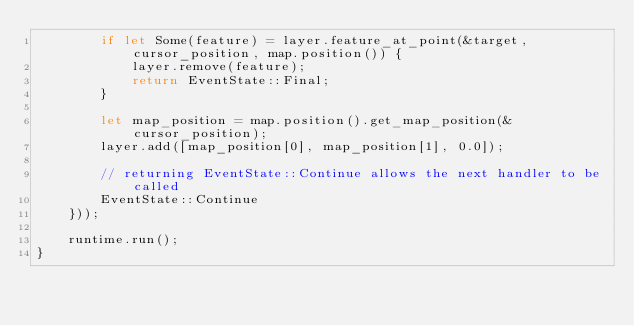Convert code to text. <code><loc_0><loc_0><loc_500><loc_500><_Rust_>        if let Some(feature) = layer.feature_at_point(&target, cursor_position, map.position()) {
            layer.remove(feature);
            return EventState::Final;
        }

        let map_position = map.position().get_map_position(&cursor_position);
        layer.add([map_position[0], map_position[1], 0.0]);

        // returning EventState::Continue allows the next handler to be called
        EventState::Continue
    }));

    runtime.run();
}
</code> 